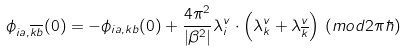Convert formula to latex. <formula><loc_0><loc_0><loc_500><loc_500>\phi _ { i a , \overline { k } \overline { b } } ( 0 ) = - \phi _ { i a , k b } ( 0 ) + \frac { 4 \pi ^ { 2 } } { | \beta ^ { 2 } | } \lambda _ { i } ^ { v } \cdot \left ( \lambda ^ { v } _ { k } + \lambda _ { \overline { k } } ^ { v } \right ) \, ( m o d 2 \pi \hbar { ) }</formula> 